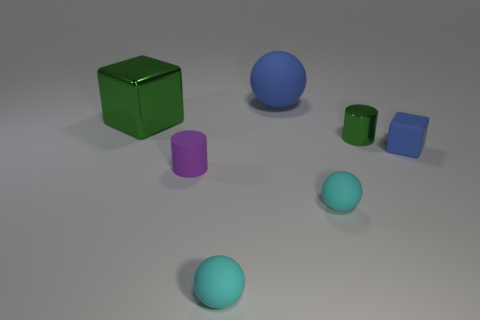Subtract all blue rubber balls. How many balls are left? 2 Subtract all yellow cylinders. How many cyan spheres are left? 2 Add 3 purple matte cylinders. How many objects exist? 10 Subtract 1 balls. How many balls are left? 2 Subtract all cubes. How many objects are left? 5 Subtract all yellow spheres. Subtract all purple cubes. How many spheres are left? 3 Subtract all big matte spheres. Subtract all blue rubber objects. How many objects are left? 4 Add 3 small blue rubber things. How many small blue rubber things are left? 4 Add 2 purple things. How many purple things exist? 3 Subtract 0 cyan blocks. How many objects are left? 7 